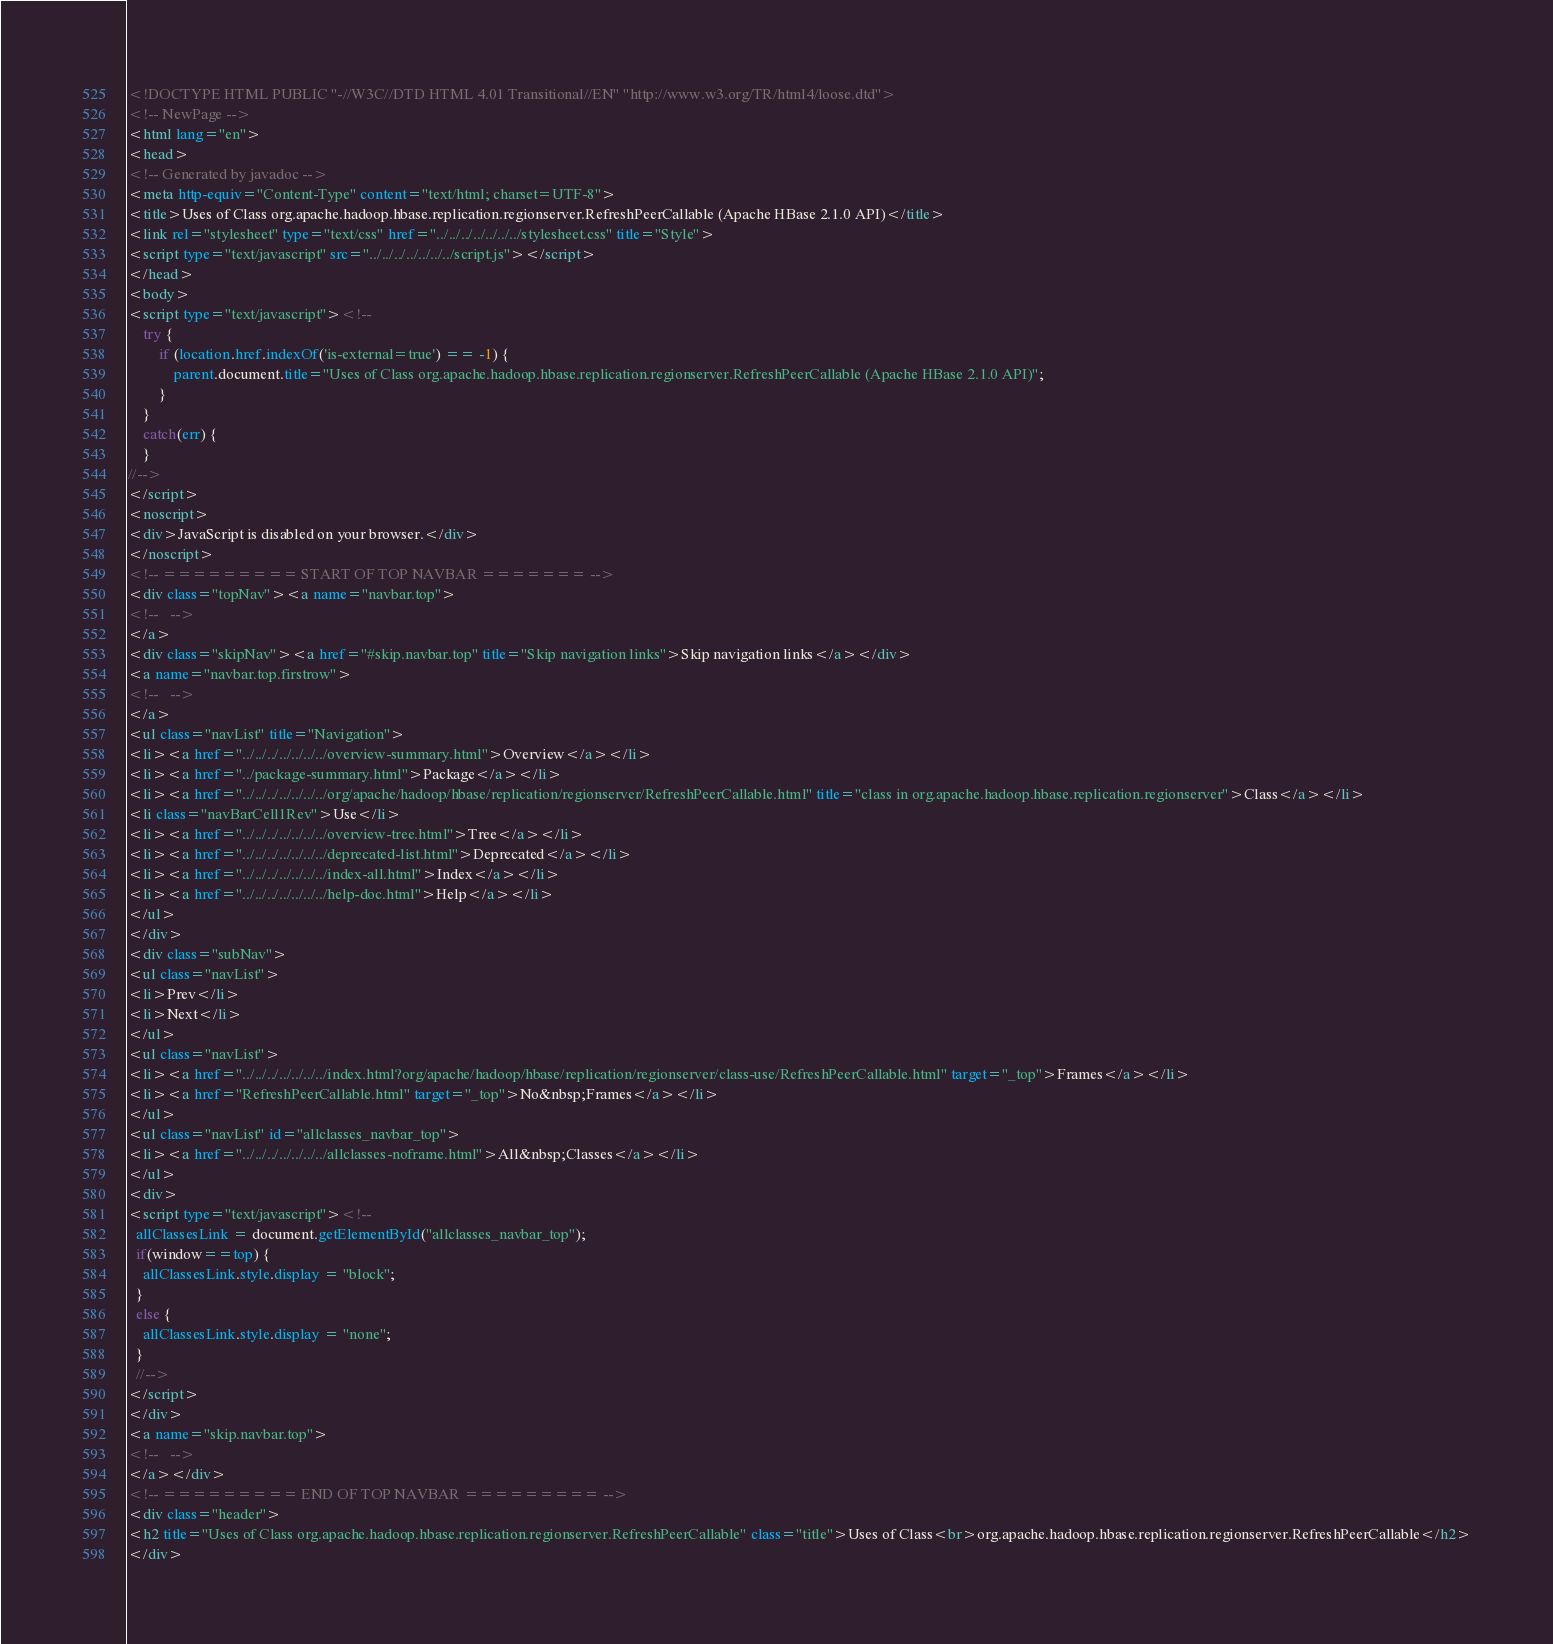<code> <loc_0><loc_0><loc_500><loc_500><_HTML_><!DOCTYPE HTML PUBLIC "-//W3C//DTD HTML 4.01 Transitional//EN" "http://www.w3.org/TR/html4/loose.dtd">
<!-- NewPage -->
<html lang="en">
<head>
<!-- Generated by javadoc -->
<meta http-equiv="Content-Type" content="text/html; charset=UTF-8">
<title>Uses of Class org.apache.hadoop.hbase.replication.regionserver.RefreshPeerCallable (Apache HBase 2.1.0 API)</title>
<link rel="stylesheet" type="text/css" href="../../../../../../../stylesheet.css" title="Style">
<script type="text/javascript" src="../../../../../../../script.js"></script>
</head>
<body>
<script type="text/javascript"><!--
    try {
        if (location.href.indexOf('is-external=true') == -1) {
            parent.document.title="Uses of Class org.apache.hadoop.hbase.replication.regionserver.RefreshPeerCallable (Apache HBase 2.1.0 API)";
        }
    }
    catch(err) {
    }
//-->
</script>
<noscript>
<div>JavaScript is disabled on your browser.</div>
</noscript>
<!-- ========= START OF TOP NAVBAR ======= -->
<div class="topNav"><a name="navbar.top">
<!--   -->
</a>
<div class="skipNav"><a href="#skip.navbar.top" title="Skip navigation links">Skip navigation links</a></div>
<a name="navbar.top.firstrow">
<!--   -->
</a>
<ul class="navList" title="Navigation">
<li><a href="../../../../../../../overview-summary.html">Overview</a></li>
<li><a href="../package-summary.html">Package</a></li>
<li><a href="../../../../../../../org/apache/hadoop/hbase/replication/regionserver/RefreshPeerCallable.html" title="class in org.apache.hadoop.hbase.replication.regionserver">Class</a></li>
<li class="navBarCell1Rev">Use</li>
<li><a href="../../../../../../../overview-tree.html">Tree</a></li>
<li><a href="../../../../../../../deprecated-list.html">Deprecated</a></li>
<li><a href="../../../../../../../index-all.html">Index</a></li>
<li><a href="../../../../../../../help-doc.html">Help</a></li>
</ul>
</div>
<div class="subNav">
<ul class="navList">
<li>Prev</li>
<li>Next</li>
</ul>
<ul class="navList">
<li><a href="../../../../../../../index.html?org/apache/hadoop/hbase/replication/regionserver/class-use/RefreshPeerCallable.html" target="_top">Frames</a></li>
<li><a href="RefreshPeerCallable.html" target="_top">No&nbsp;Frames</a></li>
</ul>
<ul class="navList" id="allclasses_navbar_top">
<li><a href="../../../../../../../allclasses-noframe.html">All&nbsp;Classes</a></li>
</ul>
<div>
<script type="text/javascript"><!--
  allClassesLink = document.getElementById("allclasses_navbar_top");
  if(window==top) {
    allClassesLink.style.display = "block";
  }
  else {
    allClassesLink.style.display = "none";
  }
  //-->
</script>
</div>
<a name="skip.navbar.top">
<!--   -->
</a></div>
<!-- ========= END OF TOP NAVBAR ========= -->
<div class="header">
<h2 title="Uses of Class org.apache.hadoop.hbase.replication.regionserver.RefreshPeerCallable" class="title">Uses of Class<br>org.apache.hadoop.hbase.replication.regionserver.RefreshPeerCallable</h2>
</div></code> 